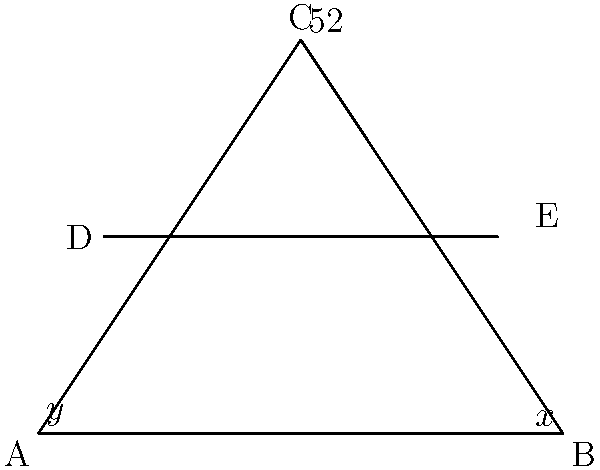In the diagram representing Jaylon Jones's defensive stance, triangle ABC shows his body position. If the angle at C is 52°, and DE is parallel to AB, what is the value of $x + y$? Let's approach this step-by-step:

1) In triangle ABC, we know that the sum of all angles must be 180°:
   $x° + y° + 52° = 180°$

2) DE is parallel to AB, which creates corresponding angles. This means:
   - The angle at D is equal to $y°$
   - The angle at E is equal to $x°$

3) In triangle CDE, we can use the fact that the sum of angles in a triangle is 180°:
   $y° + x° + 52° = 180°$

4) This equation is identical to the one we got for triangle ABC, which confirms our reasoning.

5) We can rearrange this equation:
   $x° + y° = 180° - 52°$
   $x° + y° = 128°$

Therefore, the sum of $x$ and $y$ is 128°.
Answer: 128° 